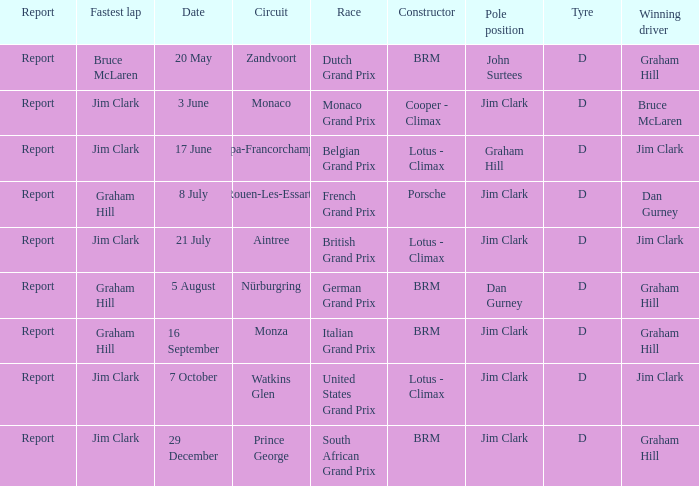What is the constructor at the United States Grand Prix? Lotus - Climax. 